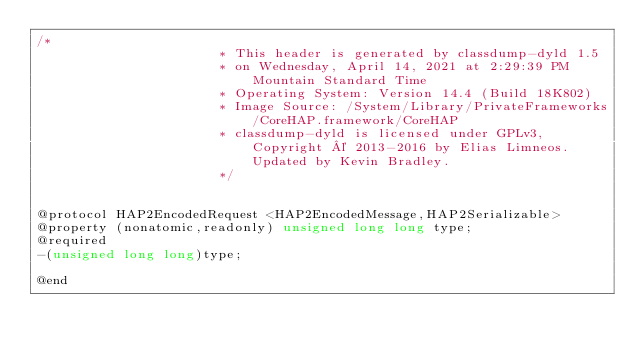<code> <loc_0><loc_0><loc_500><loc_500><_C_>/*
                       * This header is generated by classdump-dyld 1.5
                       * on Wednesday, April 14, 2021 at 2:29:39 PM Mountain Standard Time
                       * Operating System: Version 14.4 (Build 18K802)
                       * Image Source: /System/Library/PrivateFrameworks/CoreHAP.framework/CoreHAP
                       * classdump-dyld is licensed under GPLv3, Copyright © 2013-2016 by Elias Limneos. Updated by Kevin Bradley.
                       */


@protocol HAP2EncodedRequest <HAP2EncodedMessage,HAP2Serializable>
@property (nonatomic,readonly) unsigned long long type; 
@required
-(unsigned long long)type;

@end

</code> 